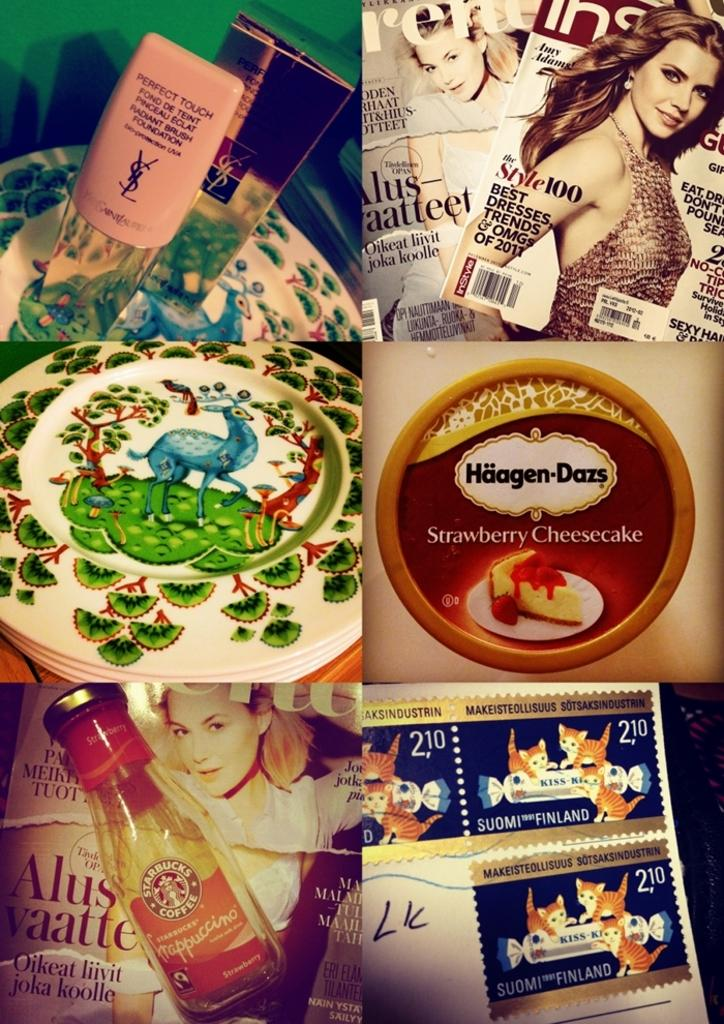<image>
Write a terse but informative summary of the picture. Middle picture on the right is Haagen Dazs ice cream 